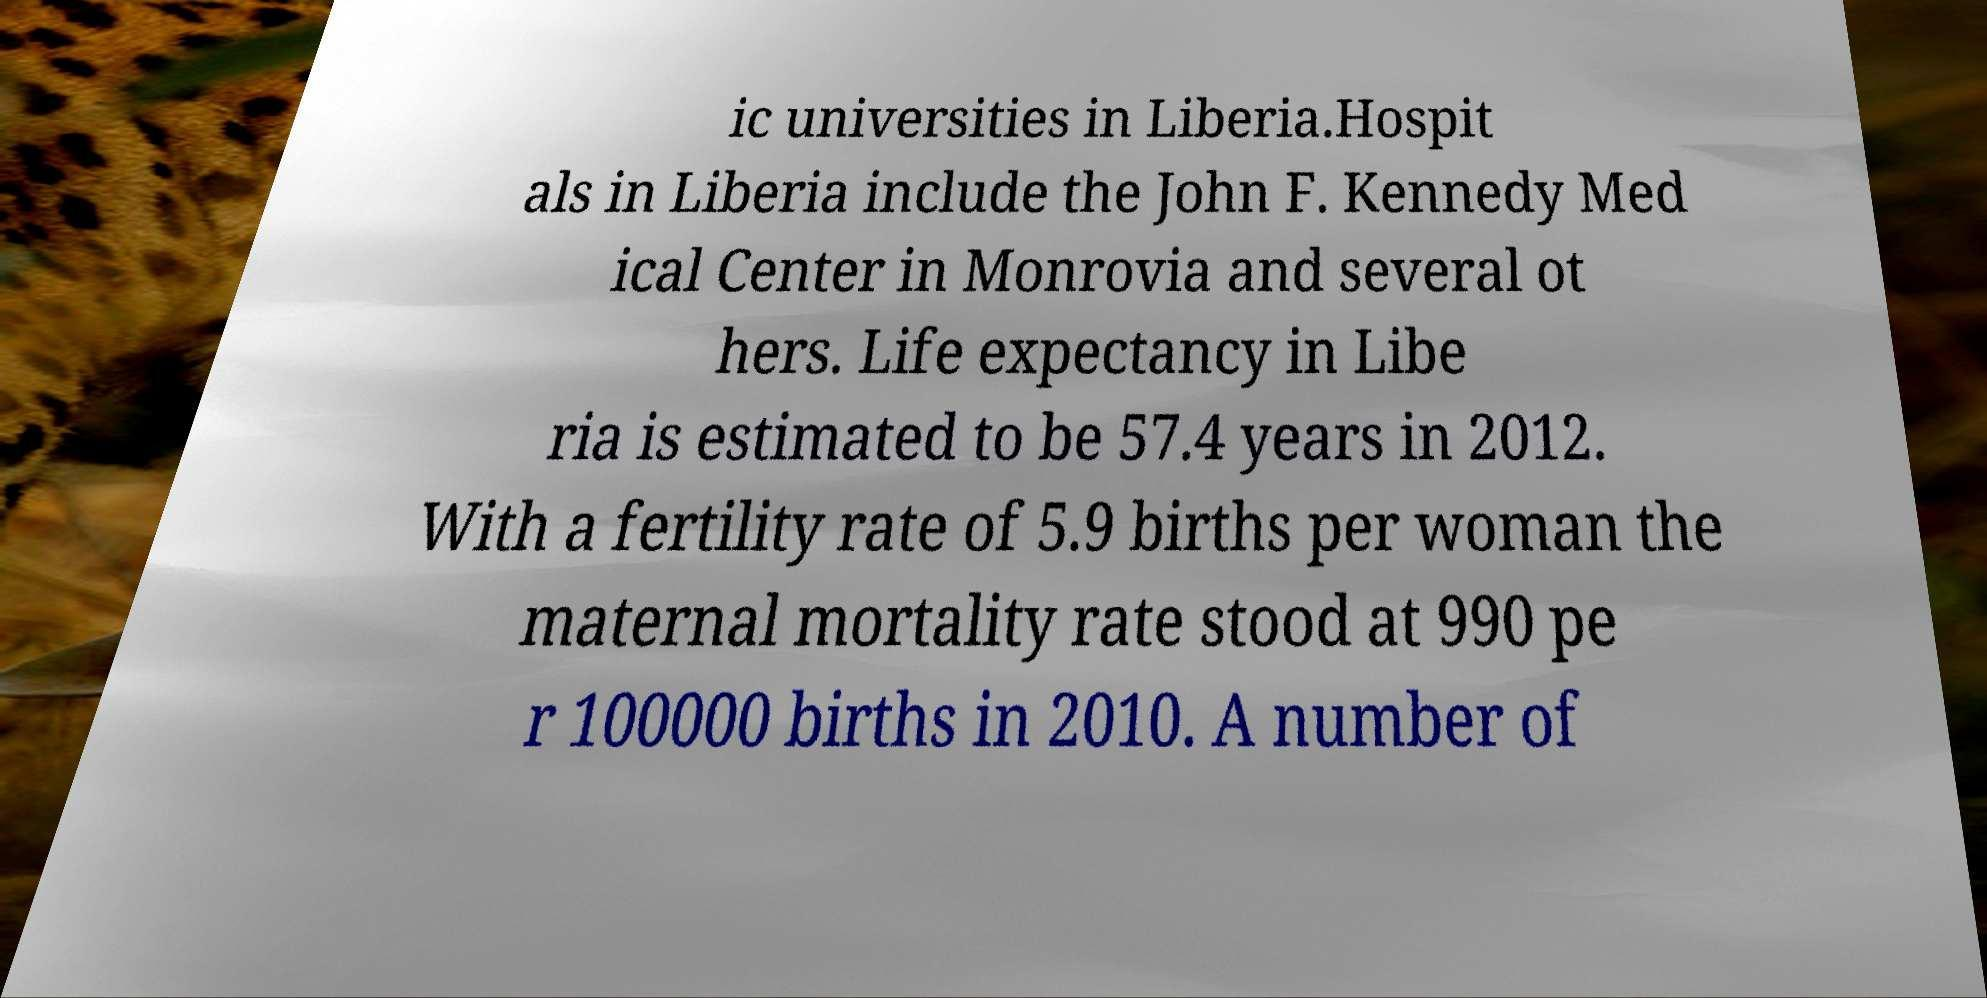What messages or text are displayed in this image? I need them in a readable, typed format. ic universities in Liberia.Hospit als in Liberia include the John F. Kennedy Med ical Center in Monrovia and several ot hers. Life expectancy in Libe ria is estimated to be 57.4 years in 2012. With a fertility rate of 5.9 births per woman the maternal mortality rate stood at 990 pe r 100000 births in 2010. A number of 